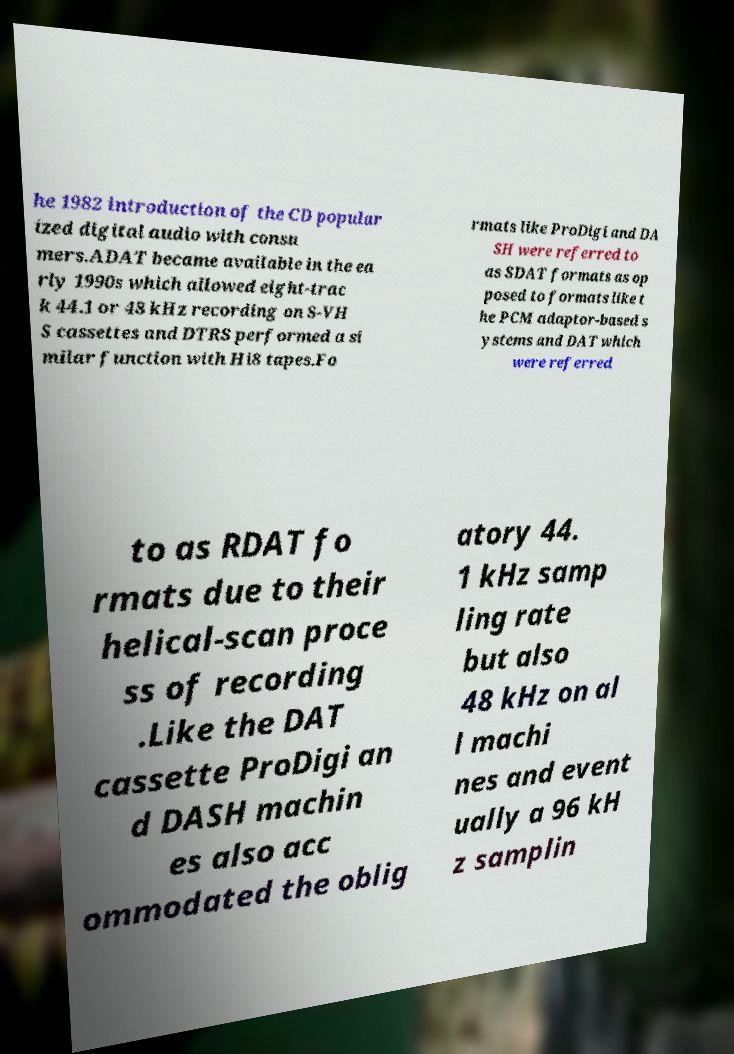I need the written content from this picture converted into text. Can you do that? he 1982 introduction of the CD popular ized digital audio with consu mers.ADAT became available in the ea rly 1990s which allowed eight-trac k 44.1 or 48 kHz recording on S-VH S cassettes and DTRS performed a si milar function with Hi8 tapes.Fo rmats like ProDigi and DA SH were referred to as SDAT formats as op posed to formats like t he PCM adaptor-based s ystems and DAT which were referred to as RDAT fo rmats due to their helical-scan proce ss of recording .Like the DAT cassette ProDigi an d DASH machin es also acc ommodated the oblig atory 44. 1 kHz samp ling rate but also 48 kHz on al l machi nes and event ually a 96 kH z samplin 